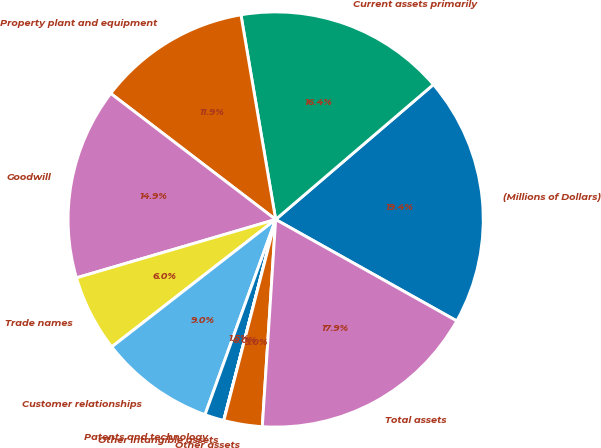<chart> <loc_0><loc_0><loc_500><loc_500><pie_chart><fcel>(Millions of Dollars)<fcel>Current assets primarily<fcel>Property plant and equipment<fcel>Goodwill<fcel>Trade names<fcel>Customer relationships<fcel>Patents and technology<fcel>Other intangible assets<fcel>Other assets<fcel>Total assets<nl><fcel>19.39%<fcel>16.41%<fcel>11.94%<fcel>14.92%<fcel>5.98%<fcel>8.96%<fcel>1.5%<fcel>0.01%<fcel>2.99%<fcel>17.9%<nl></chart> 